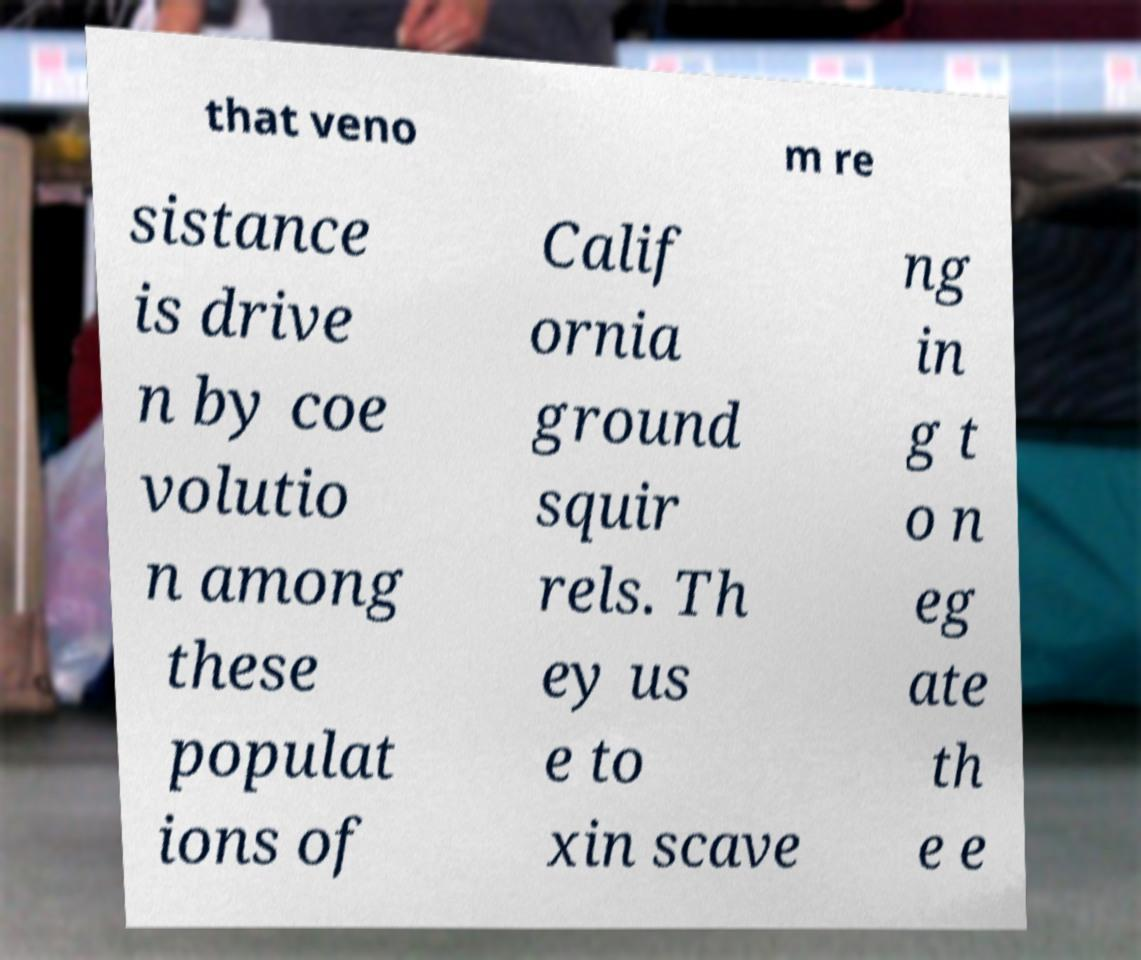For documentation purposes, I need the text within this image transcribed. Could you provide that? that veno m re sistance is drive n by coe volutio n among these populat ions of Calif ornia ground squir rels. Th ey us e to xin scave ng in g t o n eg ate th e e 